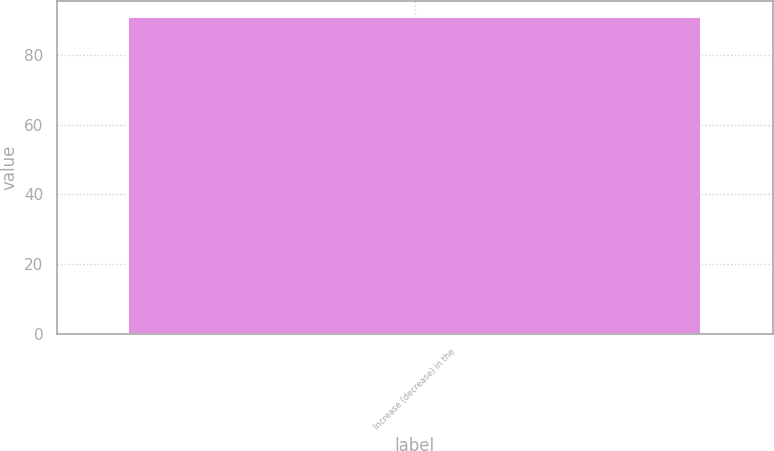Convert chart. <chart><loc_0><loc_0><loc_500><loc_500><bar_chart><fcel>Increase (decrease) in the<nl><fcel>91<nl></chart> 